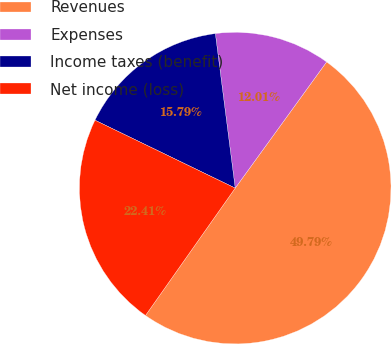<chart> <loc_0><loc_0><loc_500><loc_500><pie_chart><fcel>Revenues<fcel>Expenses<fcel>Income taxes (benefit)<fcel>Net income (loss)<nl><fcel>49.79%<fcel>12.01%<fcel>15.79%<fcel>22.41%<nl></chart> 